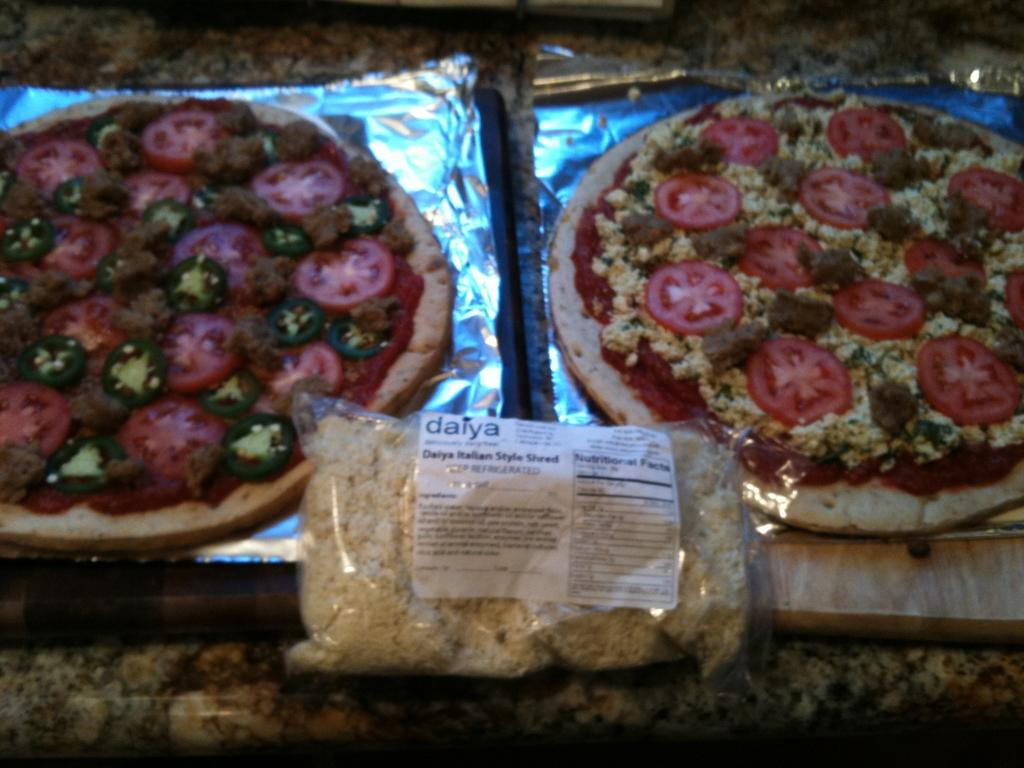What type of food can be seen in the image? There are pizzas in the image. Are there any other types of food visible in the image? Yes, there is food in a plastic cover in the image. What type of scissors can be seen cutting the brick in the image? There are no scissors or bricks present in the image. What is the cause of the food in the plastic cover in the image? The provided facts do not mention the cause of the food in the plastic cover, so we cannot determine the cause from the image. 